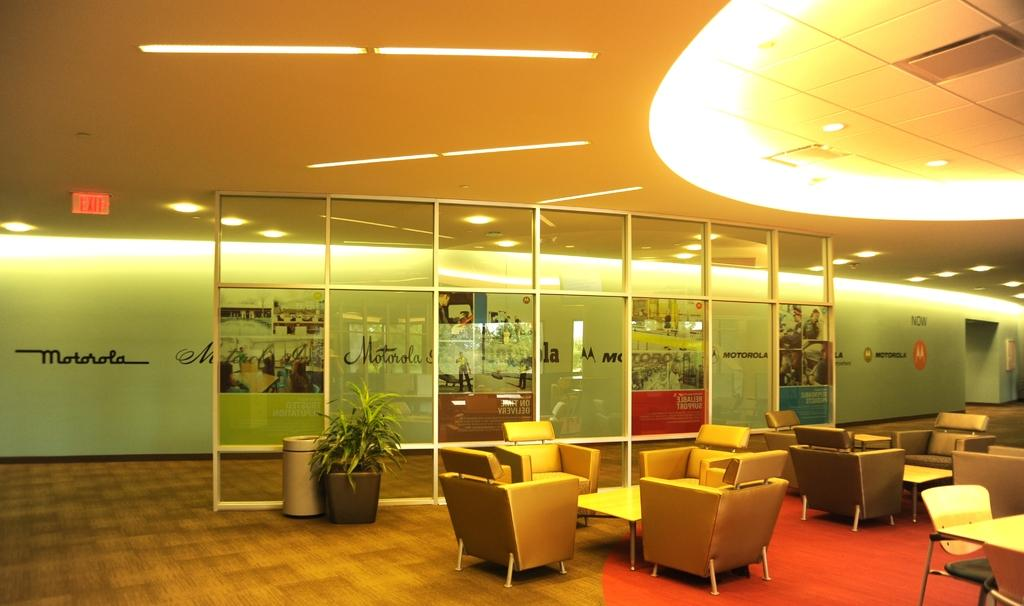What type of furniture can be seen in the image? There are tables and chairs in the image. What is used for waste disposal in the image? There is a dustbin in the image. What is used for decoration or greenery in the image? There is a plant pot in the image. What type of flooring is present in the image? There is a carpet in the image. What can be seen in the background of the image? There is a wall, a roof, lights, banners, and a few other objects in the background of the image. What type of machine is used for playing basketball in the image? There is no machine or basketball present in the image. What type of books can be found in the library in the image? There is no library present in the image. 